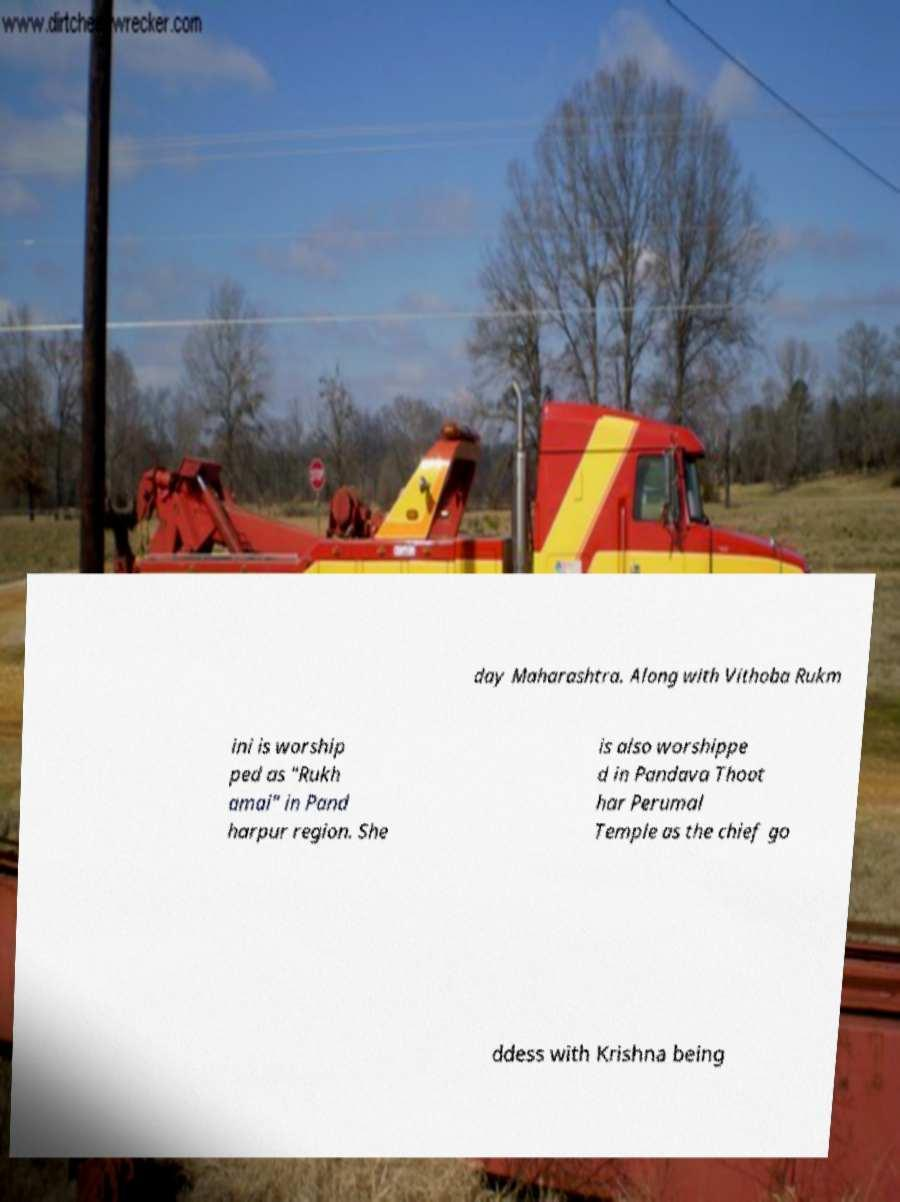Could you extract and type out the text from this image? day Maharashtra. Along with Vithoba Rukm ini is worship ped as "Rukh amai" in Pand harpur region. She is also worshippe d in Pandava Thoot har Perumal Temple as the chief go ddess with Krishna being 